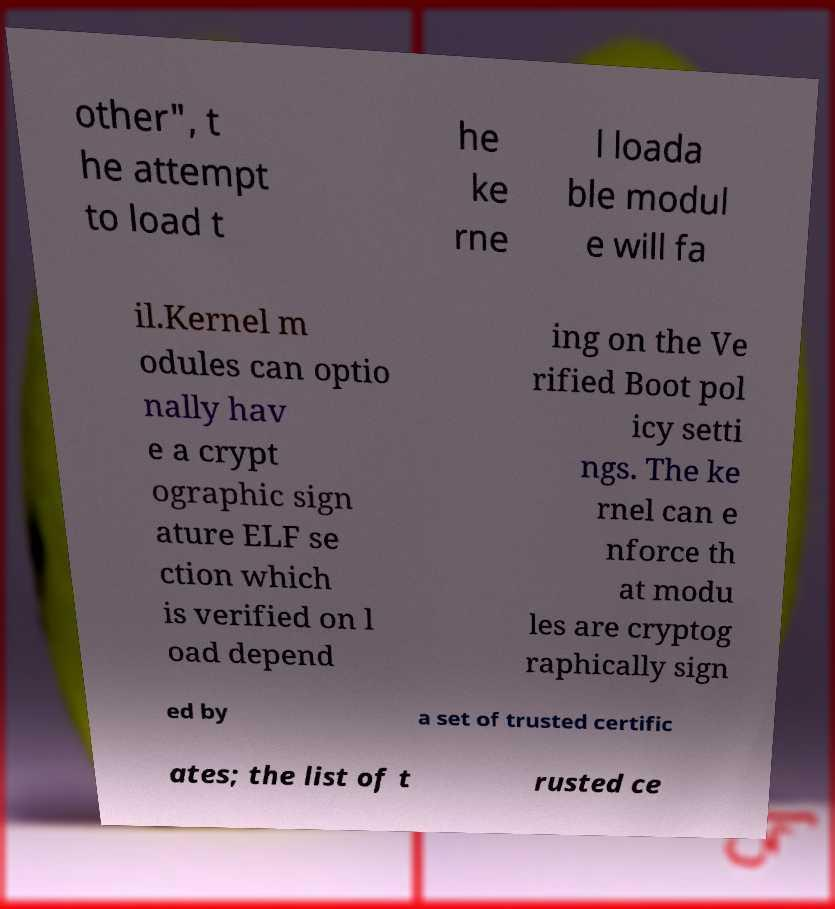Could you assist in decoding the text presented in this image and type it out clearly? other", t he attempt to load t he ke rne l loada ble modul e will fa il.Kernel m odules can optio nally hav e a crypt ographic sign ature ELF se ction which is verified on l oad depend ing on the Ve rified Boot pol icy setti ngs. The ke rnel can e nforce th at modu les are cryptog raphically sign ed by a set of trusted certific ates; the list of t rusted ce 